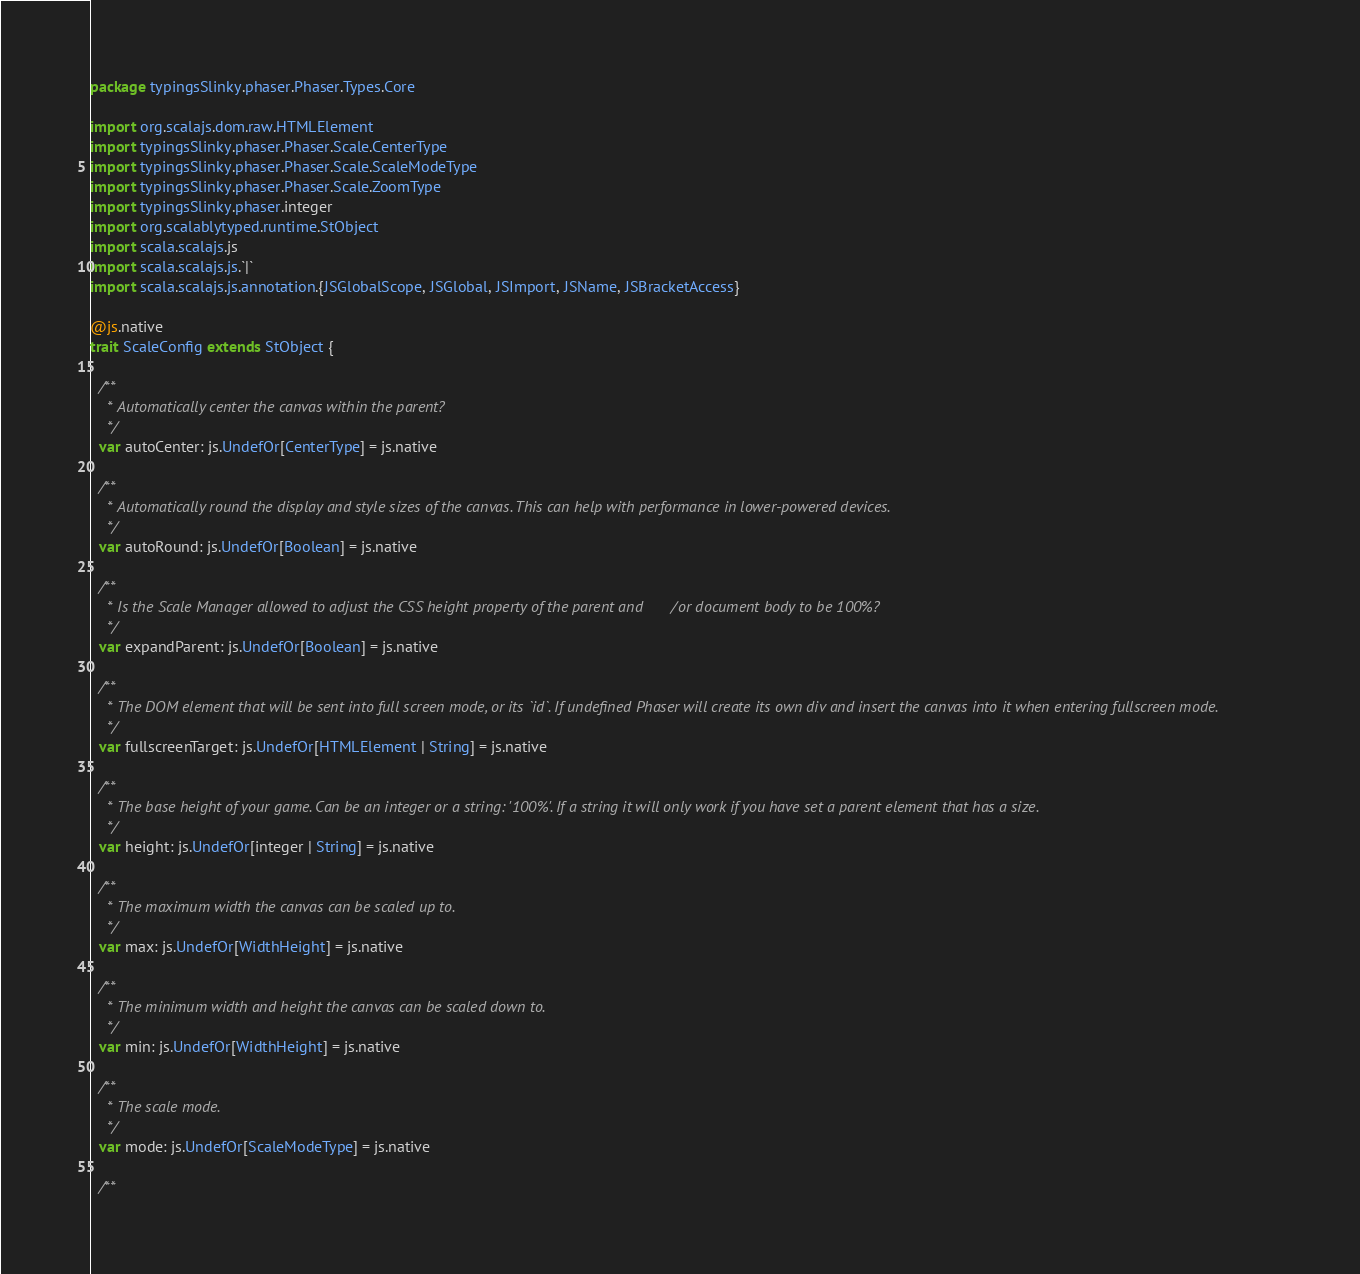Convert code to text. <code><loc_0><loc_0><loc_500><loc_500><_Scala_>package typingsSlinky.phaser.Phaser.Types.Core

import org.scalajs.dom.raw.HTMLElement
import typingsSlinky.phaser.Phaser.Scale.CenterType
import typingsSlinky.phaser.Phaser.Scale.ScaleModeType
import typingsSlinky.phaser.Phaser.Scale.ZoomType
import typingsSlinky.phaser.integer
import org.scalablytyped.runtime.StObject
import scala.scalajs.js
import scala.scalajs.js.`|`
import scala.scalajs.js.annotation.{JSGlobalScope, JSGlobal, JSImport, JSName, JSBracketAccess}

@js.native
trait ScaleConfig extends StObject {
  
  /**
    * Automatically center the canvas within the parent?
    */
  var autoCenter: js.UndefOr[CenterType] = js.native
  
  /**
    * Automatically round the display and style sizes of the canvas. This can help with performance in lower-powered devices.
    */
  var autoRound: js.UndefOr[Boolean] = js.native
  
  /**
    * Is the Scale Manager allowed to adjust the CSS height property of the parent and/or document body to be 100%?
    */
  var expandParent: js.UndefOr[Boolean] = js.native
  
  /**
    * The DOM element that will be sent into full screen mode, or its `id`. If undefined Phaser will create its own div and insert the canvas into it when entering fullscreen mode.
    */
  var fullscreenTarget: js.UndefOr[HTMLElement | String] = js.native
  
  /**
    * The base height of your game. Can be an integer or a string: '100%'. If a string it will only work if you have set a parent element that has a size.
    */
  var height: js.UndefOr[integer | String] = js.native
  
  /**
    * The maximum width the canvas can be scaled up to.
    */
  var max: js.UndefOr[WidthHeight] = js.native
  
  /**
    * The minimum width and height the canvas can be scaled down to.
    */
  var min: js.UndefOr[WidthHeight] = js.native
  
  /**
    * The scale mode.
    */
  var mode: js.UndefOr[ScaleModeType] = js.native
  
  /**</code> 